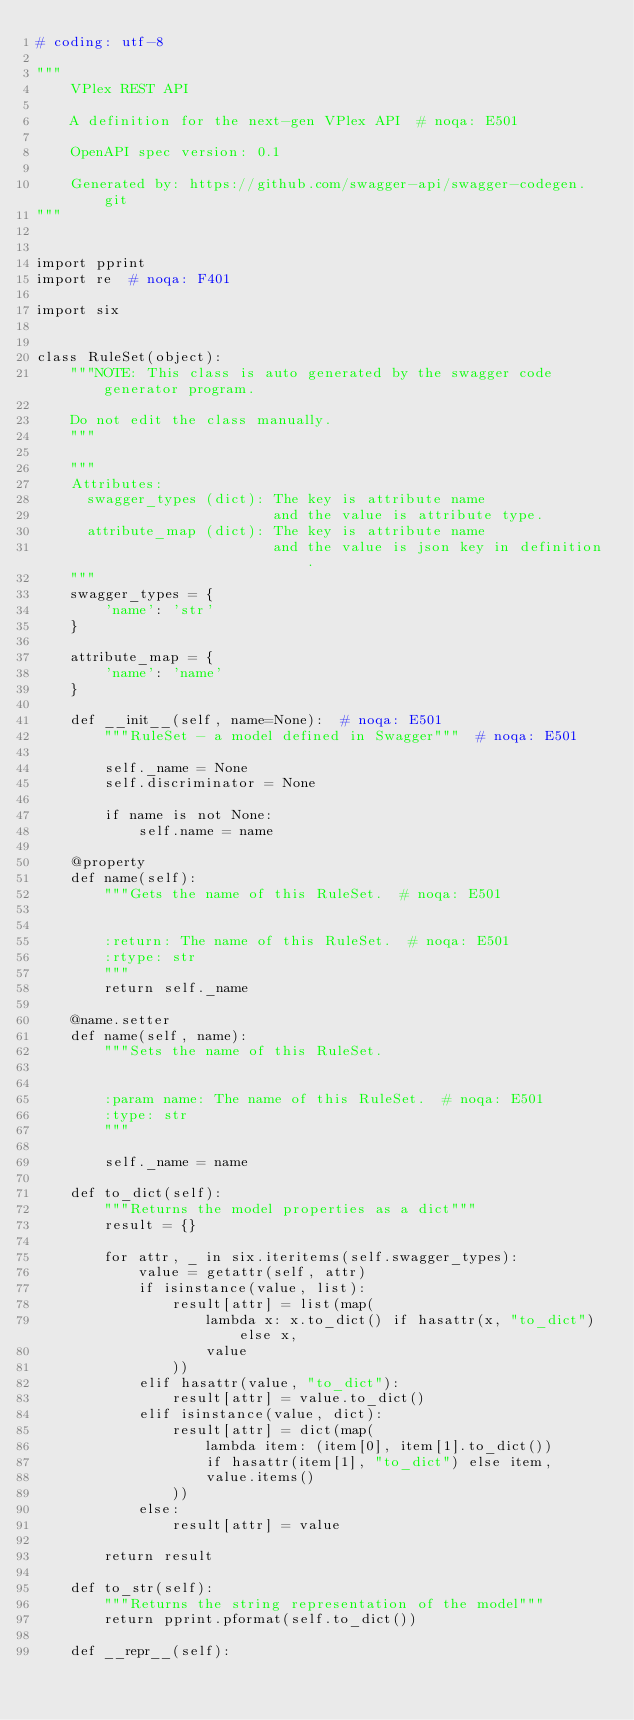Convert code to text. <code><loc_0><loc_0><loc_500><loc_500><_Python_># coding: utf-8

"""
    VPlex REST API

    A definition for the next-gen VPlex API  # noqa: E501

    OpenAPI spec version: 0.1
    
    Generated by: https://github.com/swagger-api/swagger-codegen.git
"""


import pprint
import re  # noqa: F401

import six


class RuleSet(object):
    """NOTE: This class is auto generated by the swagger code generator program.

    Do not edit the class manually.
    """

    """
    Attributes:
      swagger_types (dict): The key is attribute name
                            and the value is attribute type.
      attribute_map (dict): The key is attribute name
                            and the value is json key in definition.
    """
    swagger_types = {
        'name': 'str'
    }

    attribute_map = {
        'name': 'name'
    }

    def __init__(self, name=None):  # noqa: E501
        """RuleSet - a model defined in Swagger"""  # noqa: E501

        self._name = None
        self.discriminator = None

        if name is not None:
            self.name = name

    @property
    def name(self):
        """Gets the name of this RuleSet.  # noqa: E501


        :return: The name of this RuleSet.  # noqa: E501
        :rtype: str
        """
        return self._name

    @name.setter
    def name(self, name):
        """Sets the name of this RuleSet.


        :param name: The name of this RuleSet.  # noqa: E501
        :type: str
        """

        self._name = name

    def to_dict(self):
        """Returns the model properties as a dict"""
        result = {}

        for attr, _ in six.iteritems(self.swagger_types):
            value = getattr(self, attr)
            if isinstance(value, list):
                result[attr] = list(map(
                    lambda x: x.to_dict() if hasattr(x, "to_dict") else x,
                    value
                ))
            elif hasattr(value, "to_dict"):
                result[attr] = value.to_dict()
            elif isinstance(value, dict):
                result[attr] = dict(map(
                    lambda item: (item[0], item[1].to_dict())
                    if hasattr(item[1], "to_dict") else item,
                    value.items()
                ))
            else:
                result[attr] = value

        return result

    def to_str(self):
        """Returns the string representation of the model"""
        return pprint.pformat(self.to_dict())

    def __repr__(self):</code> 